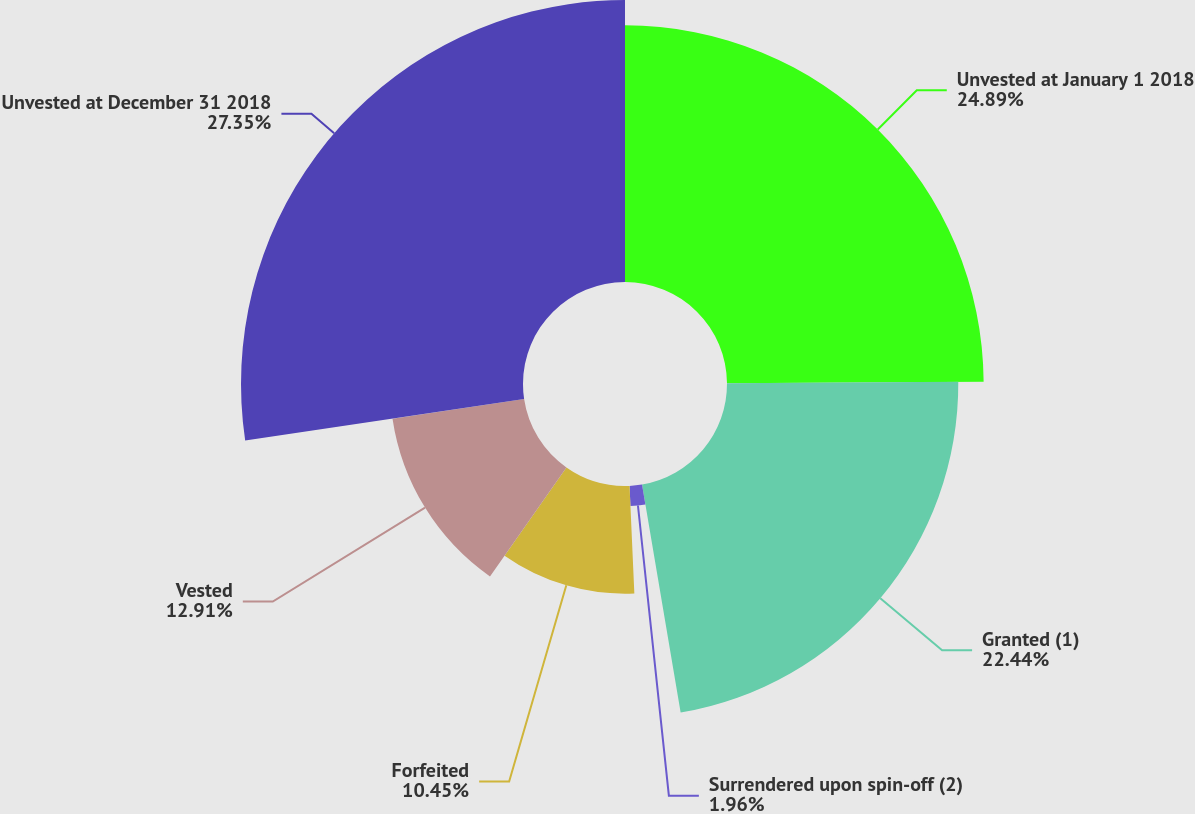Convert chart. <chart><loc_0><loc_0><loc_500><loc_500><pie_chart><fcel>Unvested at January 1 2018<fcel>Granted (1)<fcel>Surrendered upon spin-off (2)<fcel>Forfeited<fcel>Vested<fcel>Unvested at December 31 2018<nl><fcel>24.9%<fcel>22.44%<fcel>1.96%<fcel>10.45%<fcel>12.91%<fcel>27.36%<nl></chart> 